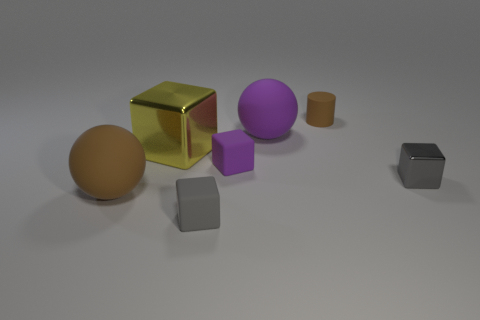Add 1 tiny gray blocks. How many objects exist? 8 Subtract all cylinders. How many objects are left? 6 Subtract all small brown matte cylinders. Subtract all small purple rubber things. How many objects are left? 5 Add 3 yellow blocks. How many yellow blocks are left? 4 Add 6 big yellow metal spheres. How many big yellow metal spheres exist? 6 Subtract 1 yellow cubes. How many objects are left? 6 